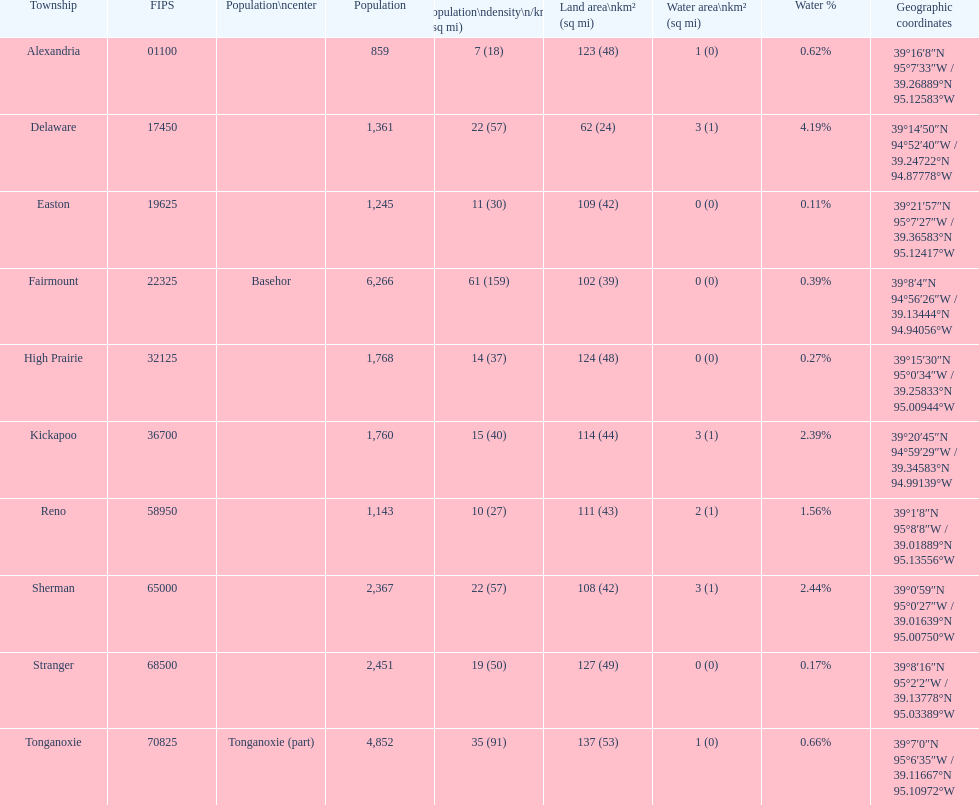Which municipality possesses the largest land area? Tonganoxie. 